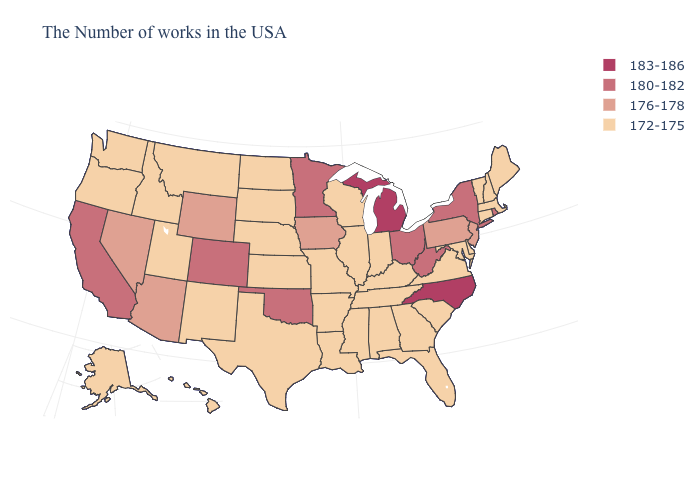Which states have the lowest value in the USA?
Concise answer only. Maine, Massachusetts, New Hampshire, Vermont, Connecticut, Delaware, Maryland, Virginia, South Carolina, Florida, Georgia, Kentucky, Indiana, Alabama, Tennessee, Wisconsin, Illinois, Mississippi, Louisiana, Missouri, Arkansas, Kansas, Nebraska, Texas, South Dakota, North Dakota, New Mexico, Utah, Montana, Idaho, Washington, Oregon, Alaska, Hawaii. What is the value of West Virginia?
Concise answer only. 180-182. What is the value of Wisconsin?
Answer briefly. 172-175. Does New Jersey have the lowest value in the USA?
Quick response, please. No. Among the states that border Idaho , which have the lowest value?
Short answer required. Utah, Montana, Washington, Oregon. What is the value of Arkansas?
Be succinct. 172-175. What is the highest value in the West ?
Answer briefly. 180-182. Name the states that have a value in the range 183-186?
Quick response, please. North Carolina, Michigan. Does Colorado have the lowest value in the USA?
Keep it brief. No. What is the value of Nevada?
Write a very short answer. 176-178. What is the value of South Carolina?
Write a very short answer. 172-175. Does the first symbol in the legend represent the smallest category?
Keep it brief. No. What is the value of New Mexico?
Short answer required. 172-175. What is the value of Iowa?
Keep it brief. 176-178. What is the highest value in the USA?
Write a very short answer. 183-186. 